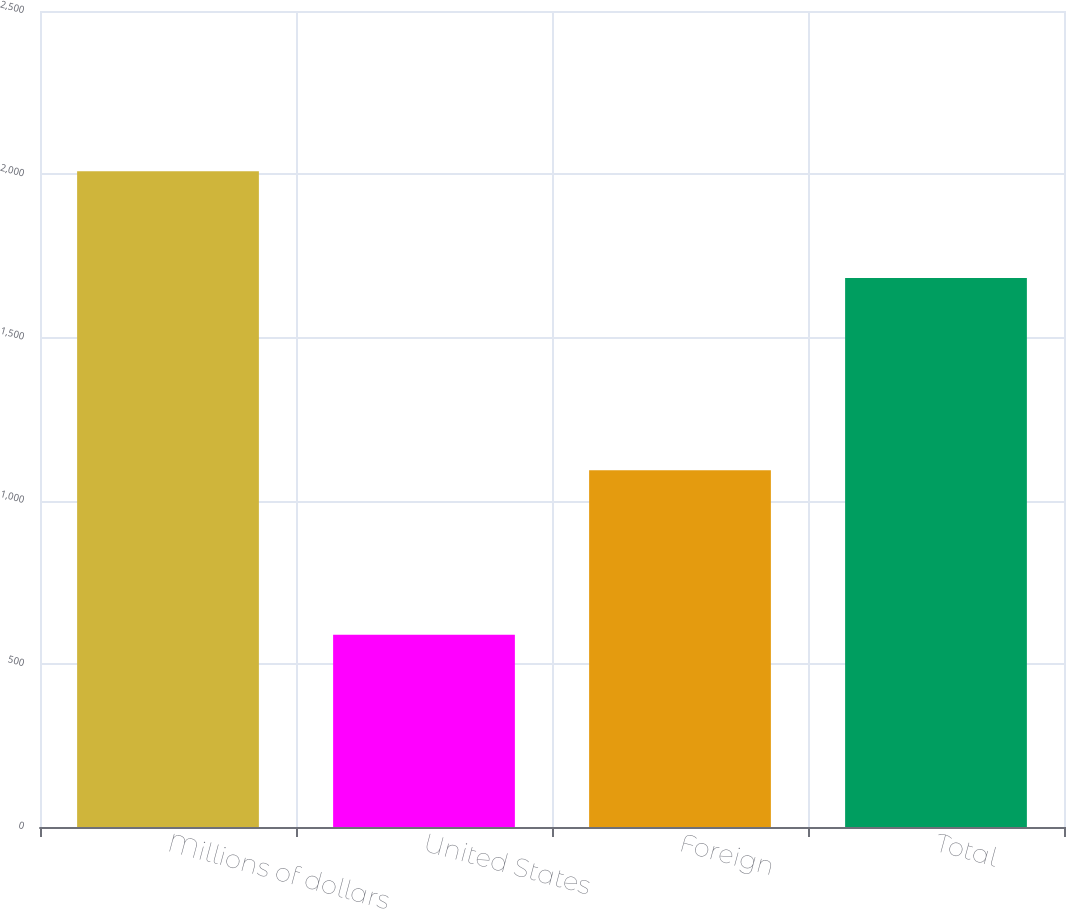<chart> <loc_0><loc_0><loc_500><loc_500><bar_chart><fcel>Millions of dollars<fcel>United States<fcel>Foreign<fcel>Total<nl><fcel>2009<fcel>589<fcel>1093<fcel>1682<nl></chart> 